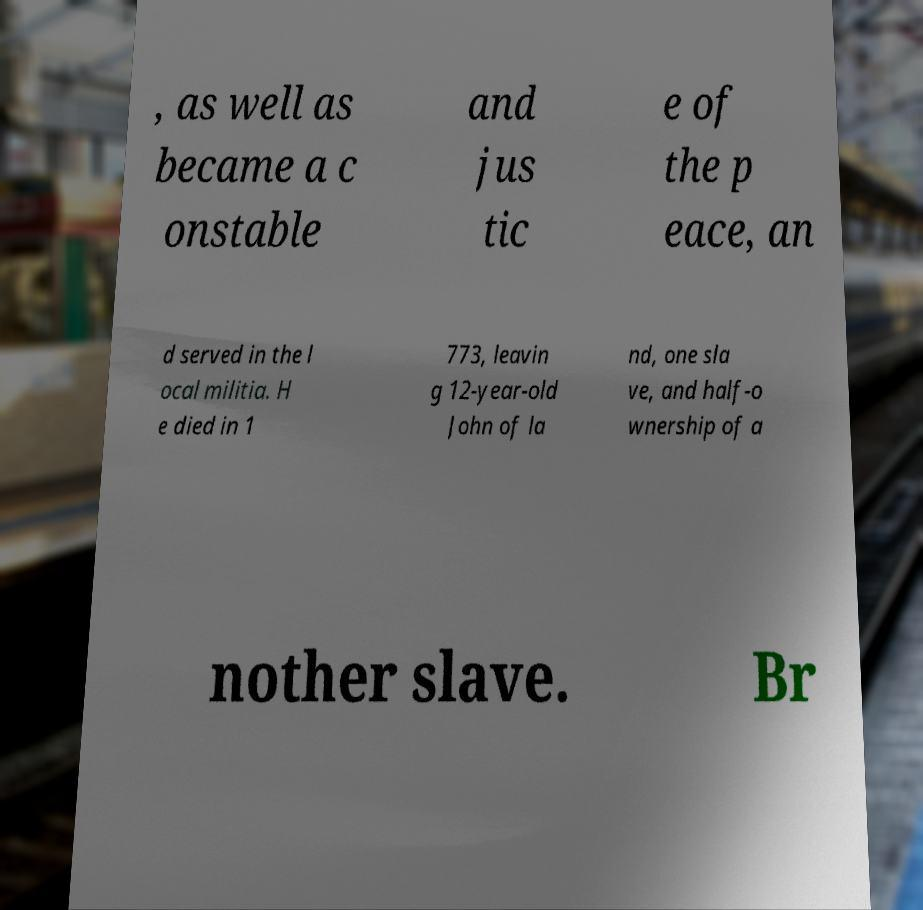Could you extract and type out the text from this image? , as well as became a c onstable and jus tic e of the p eace, an d served in the l ocal militia. H e died in 1 773, leavin g 12-year-old John of la nd, one sla ve, and half-o wnership of a nother slave. Br 